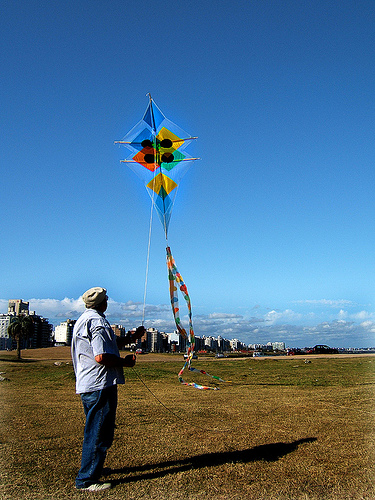Can you describe the kite being flown by the person? The kite is brightly colored with a geometric design, featuring a combination of orange, green, yellow, and blue patterns. It's a diamond-shaped kite, with a long, flowing tail setting a cheerful scene against the blue sky. 